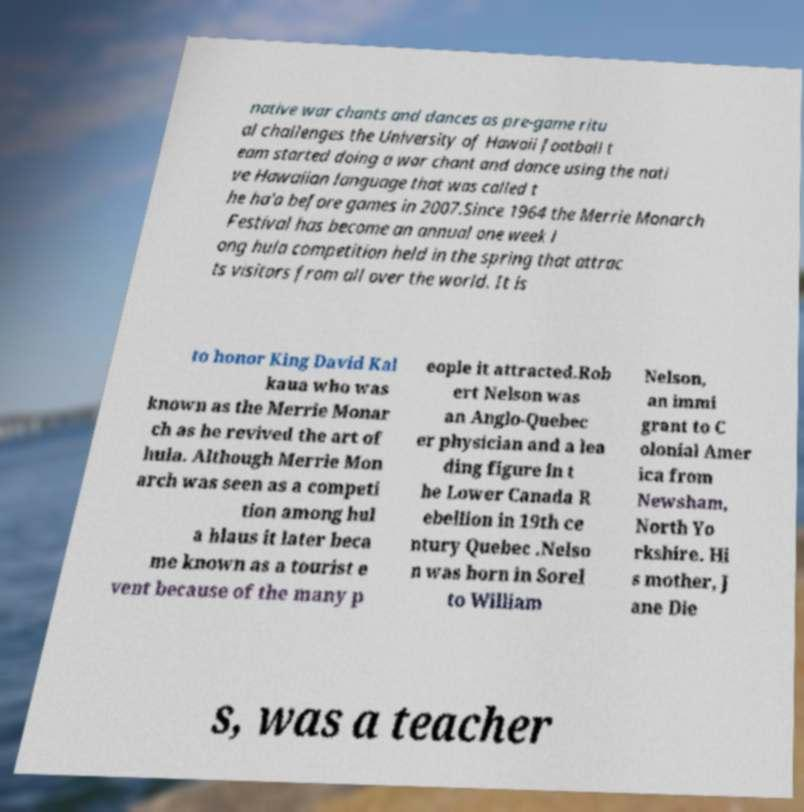Can you accurately transcribe the text from the provided image for me? native war chants and dances as pre-game ritu al challenges the University of Hawaii football t eam started doing a war chant and dance using the nati ve Hawaiian language that was called t he ha'a before games in 2007.Since 1964 the Merrie Monarch Festival has become an annual one week l ong hula competition held in the spring that attrac ts visitors from all over the world. It is to honor King David Kal kaua who was known as the Merrie Monar ch as he revived the art of hula. Although Merrie Mon arch was seen as a competi tion among hul a hlaus it later beca me known as a tourist e vent because of the many p eople it attracted.Rob ert Nelson was an Anglo-Quebec er physician and a lea ding figure in t he Lower Canada R ebellion in 19th ce ntury Quebec .Nelso n was born in Sorel to William Nelson, an immi grant to C olonial Amer ica from Newsham, North Yo rkshire. Hi s mother, J ane Die s, was a teacher 